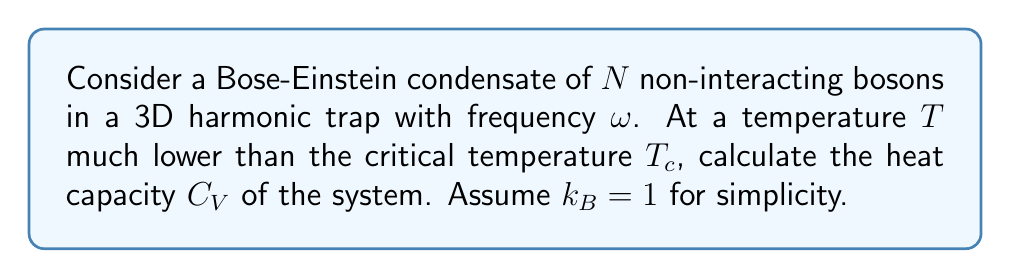Solve this math problem. To calculate the heat capacity of a Bose-Einstein condensate (BEC) in the low-temperature limit, we'll follow these steps:

1. Recall that for a BEC at $T \ll T_c$, most particles are in the ground state.

2. The energy of the excited states in a 3D harmonic trap is given by:
   $$E_n = \hbar\omega(n_x + n_y + n_z)$$
   where $n_x$, $n_y$, and $n_z$ are non-negative integers.

3. The average number of excited particles is:
   $$N_e = \sum_{n_x,n_y,n_z} \frac{1}{e^{\beta E_n} - 1}$$
   where $\beta = 1/k_BT = 1/T$ (since $k_B = 1$).

4. For low temperatures, we can approximate this sum as an integral:
   $$N_e \approx \int_0^\infty \frac{g(\epsilon)}{e^{\beta \epsilon} - 1} d\epsilon$$
   where $g(\epsilon) = \frac{\epsilon^2}{2(\hbar\omega)^3}$ is the density of states.

5. Solving this integral gives:
   $$N_e = \frac{\pi^4}{90} \left(\frac{T}{\hbar\omega}\right)^3$$

6. The total energy of the excited states is:
   $$E = \int_0^\infty \frac{\epsilon g(\epsilon)}{e^{\beta \epsilon} - 1} d\epsilon = \frac{\pi^4}{30} T^4 (\hbar\omega)^{-3}$$

7. The heat capacity is defined as $C_V = \left(\frac{\partial E}{\partial T}\right)_V$. Differentiating $E$ with respect to $T$:
   $$C_V = \frac{2\pi^4}{15} T^3 (\hbar\omega)^{-3}$$

This expression gives the heat capacity of a BEC in a 3D harmonic trap at low temperatures.
Answer: $C_V = \frac{2\pi^4}{15} T^3 (\hbar\omega)^{-3}$ 